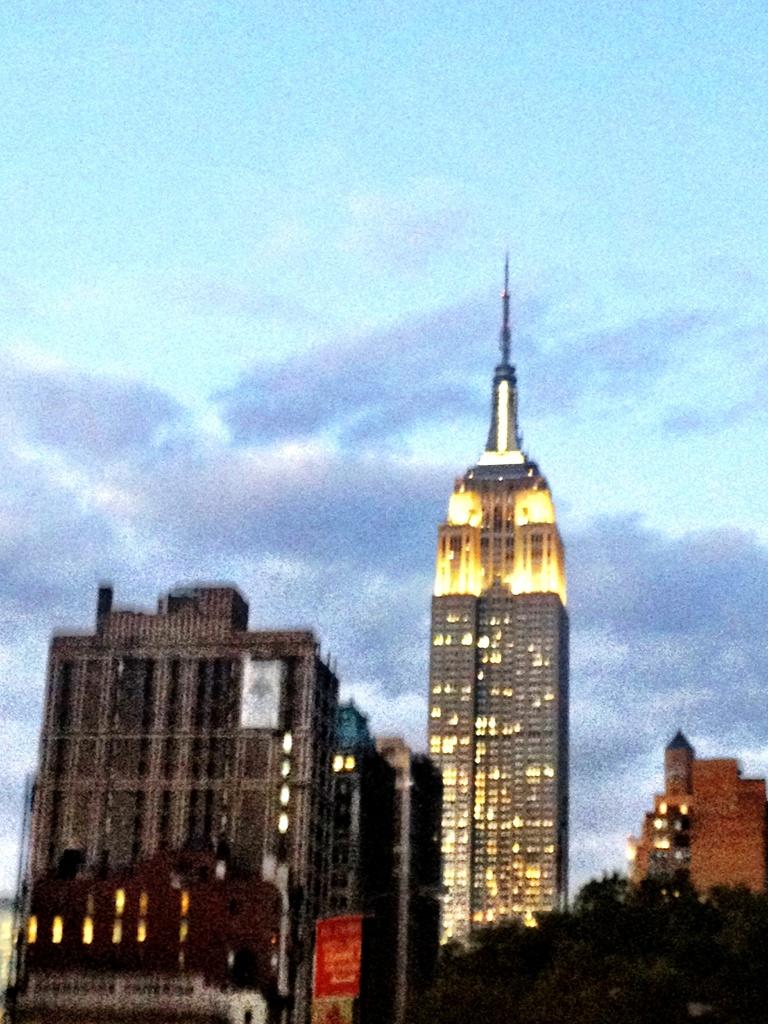What type of structures can be seen in the image? There are buildings in the image. What other natural elements are present in the image? There are trees in the image. What can be seen in the distance in the image? The sky is visible in the background of the image. Are there any dinosaurs visible in the image? No, there are no dinosaurs present in the image. 